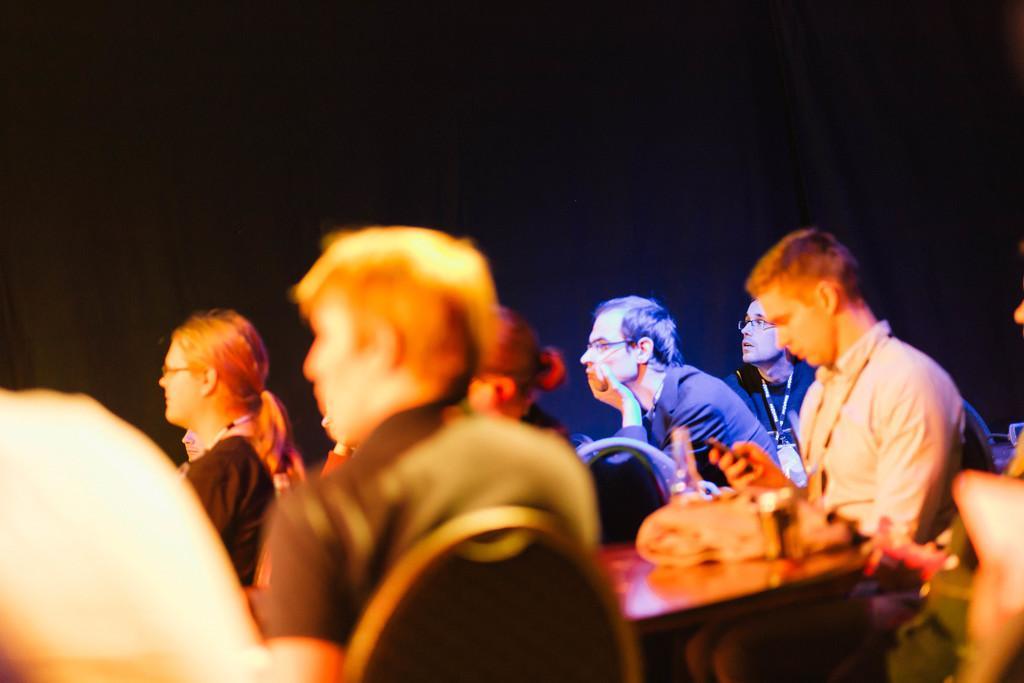In one or two sentences, can you explain what this image depicts? In this image we can see few persons sitting on the chairs in which few of them are wearing goggles, there we can see a table with a bag on it, we can see some lighting on the person's. 